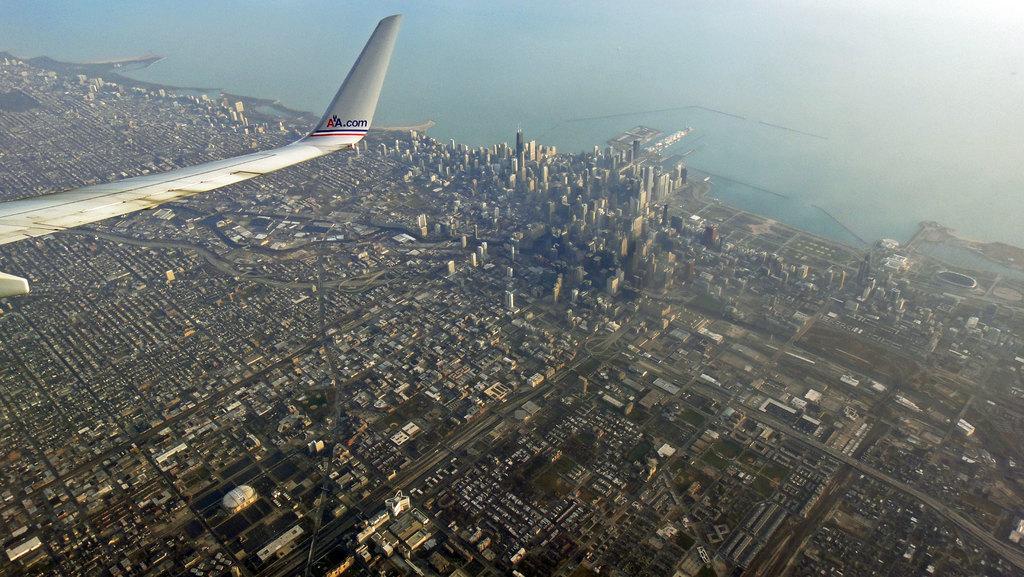Could you give a brief overview of what you see in this image? In this image when we see it from the top view there are many buildings at the bottom also there are small houses and many small buildings are present over here and there is also an ocean towards the right and there is a plane where we can see one of its wing in the image. 